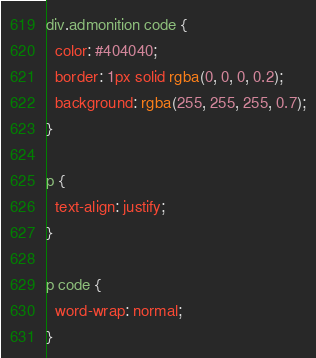Convert code to text. <code><loc_0><loc_0><loc_500><loc_500><_CSS_>div.admonition code {
  color: #404040;
  border: 1px solid rgba(0, 0, 0, 0.2);
  background: rgba(255, 255, 255, 0.7);
}

p {
  text-align: justify;
}

p code {
  word-wrap: normal;
}
</code> 